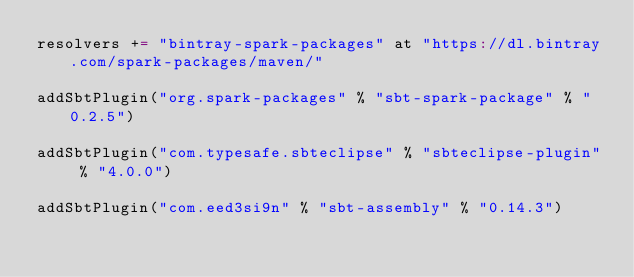<code> <loc_0><loc_0><loc_500><loc_500><_Scala_>resolvers += "bintray-spark-packages" at "https://dl.bintray.com/spark-packages/maven/"

addSbtPlugin("org.spark-packages" % "sbt-spark-package" % "0.2.5")

addSbtPlugin("com.typesafe.sbteclipse" % "sbteclipse-plugin" % "4.0.0")

addSbtPlugin("com.eed3si9n" % "sbt-assembly" % "0.14.3")

</code> 